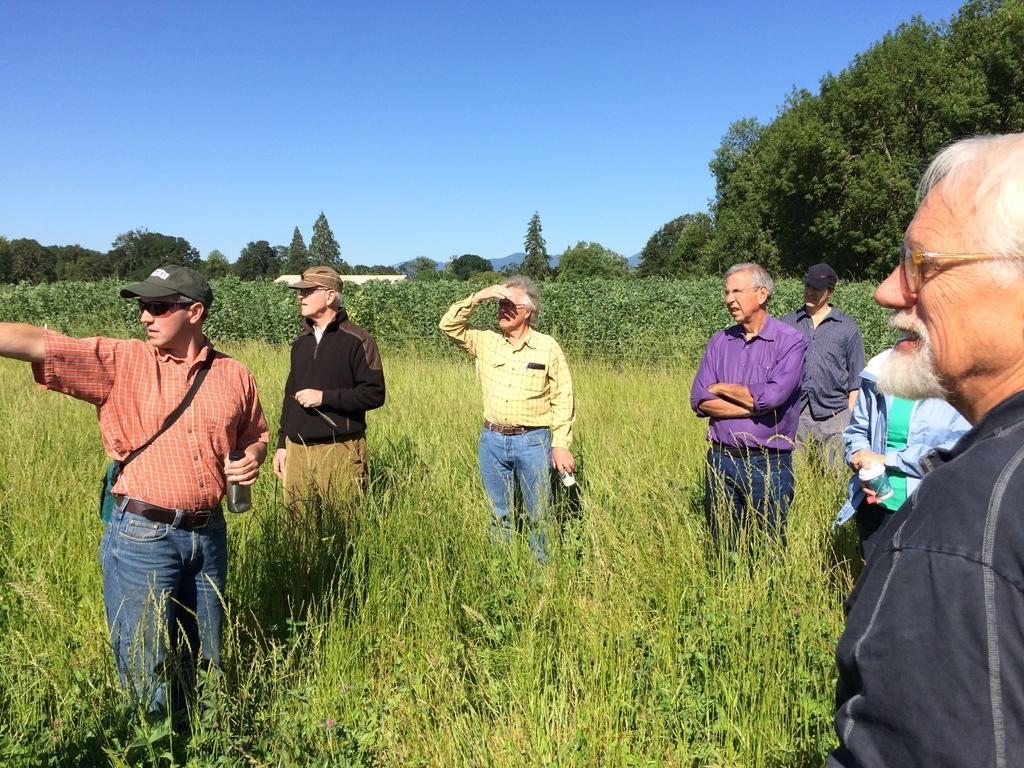How many people are in the group visible in the image? There is a group of people in the image, but the exact number is not specified. What are some people holding in the image? Some people are holding objects in the image, but the specific objects are not mentioned. What type of vegetation can be seen in the image? There are many plants and trees in the image. What is visible in the background of the image? The sky is visible in the background of the image. What type of pain can be seen on the faces of the people in the image? There is no indication of pain on the faces of the people in the image. Where is the spot where the group of people is standing in the image? The location where the group of people is standing is not specified in the image. 